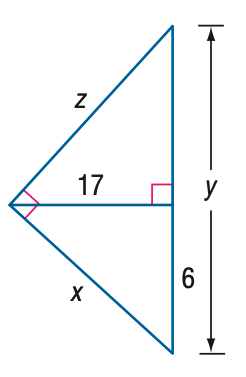Question: Find z.
Choices:
A. 17
B. \frac { 17 } { 6 } \sqrt { 253 }
C. \frac { 289 } { 6 }
D. \frac { 85 } { 6 } \sqrt { 13 }
Answer with the letter. Answer: D 